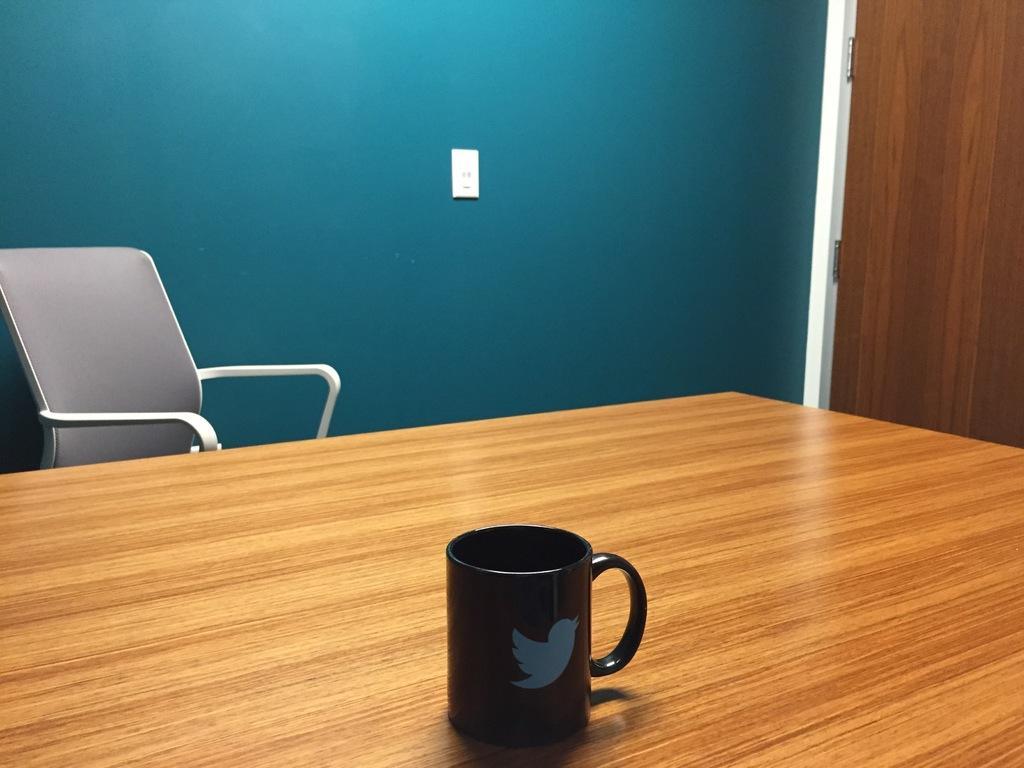How would you summarize this image in a sentence or two? this picture shows a chair and a cup on the table and we see a door 